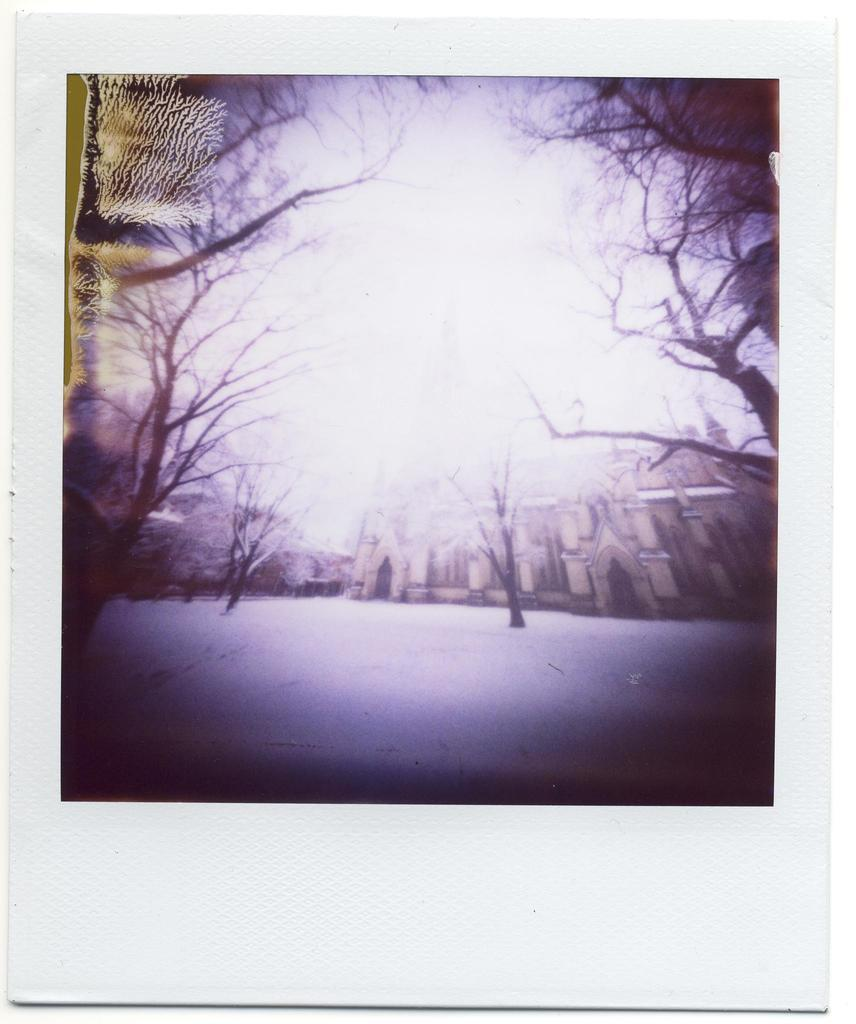What is the main subject of the image? There is a photo in the image. What can be seen in the photo? The photo contains a building, trees, and a sky. What type of tin can be seen in the yard in the image? There is no tin or yard present in the image; it only contains a photo with a building, trees, and a sky. 